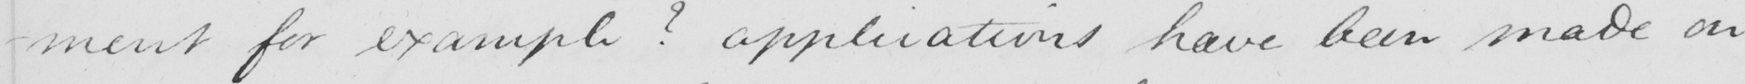What is written in this line of handwriting? -ment for example ?  applications have been made on 